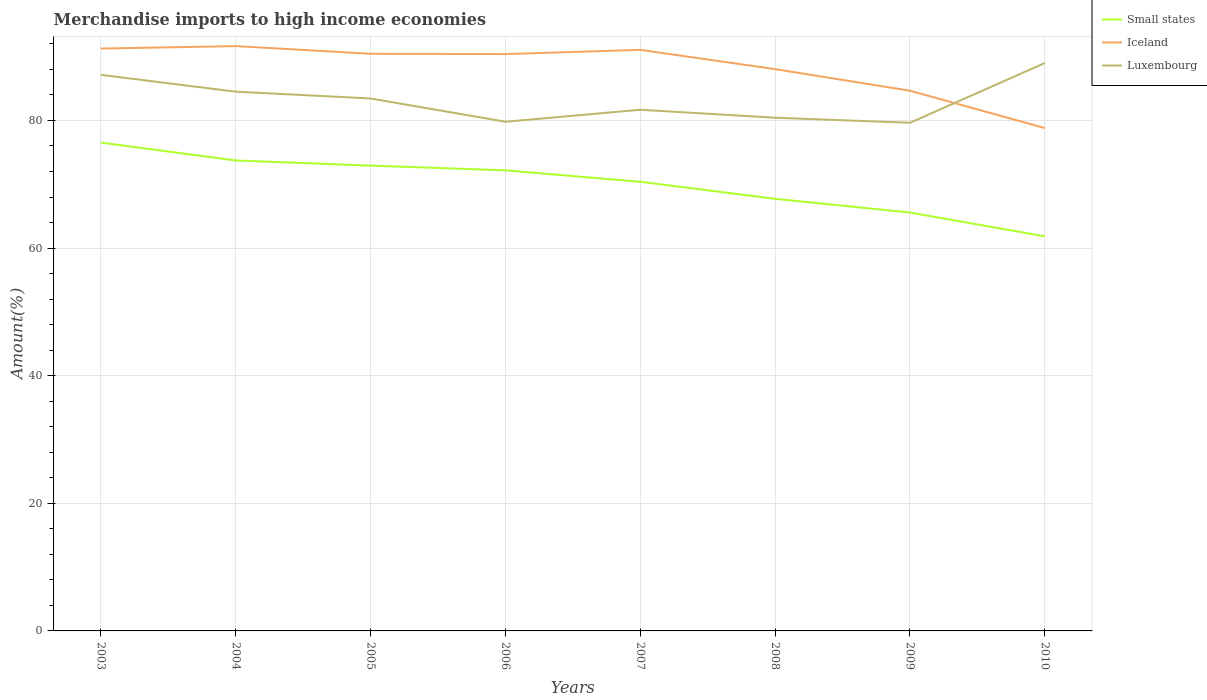Across all years, what is the maximum percentage of amount earned from merchandise imports in Luxembourg?
Offer a very short reply. 79.64. What is the total percentage of amount earned from merchandise imports in Small states in the graph?
Offer a terse response. 3.73. What is the difference between the highest and the second highest percentage of amount earned from merchandise imports in Luxembourg?
Your answer should be compact. 9.37. What is the difference between the highest and the lowest percentage of amount earned from merchandise imports in Small states?
Make the answer very short. 5. Is the percentage of amount earned from merchandise imports in Iceland strictly greater than the percentage of amount earned from merchandise imports in Luxembourg over the years?
Keep it short and to the point. No. Are the values on the major ticks of Y-axis written in scientific E-notation?
Offer a very short reply. No. Where does the legend appear in the graph?
Ensure brevity in your answer.  Top right. How many legend labels are there?
Give a very brief answer. 3. What is the title of the graph?
Your answer should be compact. Merchandise imports to high income economies. Does "Lithuania" appear as one of the legend labels in the graph?
Give a very brief answer. No. What is the label or title of the Y-axis?
Offer a terse response. Amount(%). What is the Amount(%) of Small states in 2003?
Provide a succinct answer. 76.54. What is the Amount(%) in Iceland in 2003?
Ensure brevity in your answer.  91.27. What is the Amount(%) of Luxembourg in 2003?
Keep it short and to the point. 87.15. What is the Amount(%) of Small states in 2004?
Ensure brevity in your answer.  73.73. What is the Amount(%) of Iceland in 2004?
Give a very brief answer. 91.66. What is the Amount(%) of Luxembourg in 2004?
Your response must be concise. 84.51. What is the Amount(%) in Small states in 2005?
Your response must be concise. 72.92. What is the Amount(%) of Iceland in 2005?
Provide a succinct answer. 90.45. What is the Amount(%) of Luxembourg in 2005?
Provide a short and direct response. 83.45. What is the Amount(%) in Small states in 2006?
Your response must be concise. 72.18. What is the Amount(%) of Iceland in 2006?
Offer a very short reply. 90.41. What is the Amount(%) of Luxembourg in 2006?
Provide a succinct answer. 79.8. What is the Amount(%) of Small states in 2007?
Ensure brevity in your answer.  70.39. What is the Amount(%) in Iceland in 2007?
Offer a terse response. 91.06. What is the Amount(%) in Luxembourg in 2007?
Provide a short and direct response. 81.68. What is the Amount(%) in Small states in 2008?
Give a very brief answer. 67.72. What is the Amount(%) of Iceland in 2008?
Give a very brief answer. 88.05. What is the Amount(%) in Luxembourg in 2008?
Keep it short and to the point. 80.43. What is the Amount(%) of Small states in 2009?
Your answer should be compact. 65.57. What is the Amount(%) in Iceland in 2009?
Your answer should be very brief. 84.66. What is the Amount(%) of Luxembourg in 2009?
Your response must be concise. 79.64. What is the Amount(%) of Small states in 2010?
Make the answer very short. 61.84. What is the Amount(%) in Iceland in 2010?
Your response must be concise. 78.81. What is the Amount(%) of Luxembourg in 2010?
Offer a terse response. 89. Across all years, what is the maximum Amount(%) of Small states?
Give a very brief answer. 76.54. Across all years, what is the maximum Amount(%) of Iceland?
Your response must be concise. 91.66. Across all years, what is the maximum Amount(%) of Luxembourg?
Your answer should be very brief. 89. Across all years, what is the minimum Amount(%) in Small states?
Provide a succinct answer. 61.84. Across all years, what is the minimum Amount(%) in Iceland?
Keep it short and to the point. 78.81. Across all years, what is the minimum Amount(%) in Luxembourg?
Ensure brevity in your answer.  79.64. What is the total Amount(%) of Small states in the graph?
Your answer should be compact. 560.9. What is the total Amount(%) in Iceland in the graph?
Give a very brief answer. 706.38. What is the total Amount(%) of Luxembourg in the graph?
Keep it short and to the point. 665.67. What is the difference between the Amount(%) of Small states in 2003 and that in 2004?
Ensure brevity in your answer.  2.8. What is the difference between the Amount(%) in Iceland in 2003 and that in 2004?
Your answer should be very brief. -0.39. What is the difference between the Amount(%) of Luxembourg in 2003 and that in 2004?
Offer a terse response. 2.64. What is the difference between the Amount(%) in Small states in 2003 and that in 2005?
Provide a short and direct response. 3.61. What is the difference between the Amount(%) in Iceland in 2003 and that in 2005?
Keep it short and to the point. 0.82. What is the difference between the Amount(%) in Luxembourg in 2003 and that in 2005?
Offer a very short reply. 3.7. What is the difference between the Amount(%) in Small states in 2003 and that in 2006?
Provide a short and direct response. 4.35. What is the difference between the Amount(%) in Iceland in 2003 and that in 2006?
Make the answer very short. 0.86. What is the difference between the Amount(%) of Luxembourg in 2003 and that in 2006?
Make the answer very short. 7.35. What is the difference between the Amount(%) of Small states in 2003 and that in 2007?
Your response must be concise. 6.14. What is the difference between the Amount(%) in Iceland in 2003 and that in 2007?
Ensure brevity in your answer.  0.21. What is the difference between the Amount(%) in Luxembourg in 2003 and that in 2007?
Give a very brief answer. 5.47. What is the difference between the Amount(%) in Small states in 2003 and that in 2008?
Offer a terse response. 8.82. What is the difference between the Amount(%) in Iceland in 2003 and that in 2008?
Keep it short and to the point. 3.22. What is the difference between the Amount(%) in Luxembourg in 2003 and that in 2008?
Keep it short and to the point. 6.72. What is the difference between the Amount(%) of Small states in 2003 and that in 2009?
Make the answer very short. 10.96. What is the difference between the Amount(%) in Iceland in 2003 and that in 2009?
Offer a terse response. 6.61. What is the difference between the Amount(%) of Luxembourg in 2003 and that in 2009?
Keep it short and to the point. 7.51. What is the difference between the Amount(%) in Small states in 2003 and that in 2010?
Your answer should be very brief. 14.69. What is the difference between the Amount(%) in Iceland in 2003 and that in 2010?
Ensure brevity in your answer.  12.46. What is the difference between the Amount(%) of Luxembourg in 2003 and that in 2010?
Provide a succinct answer. -1.85. What is the difference between the Amount(%) in Small states in 2004 and that in 2005?
Provide a short and direct response. 0.81. What is the difference between the Amount(%) in Iceland in 2004 and that in 2005?
Give a very brief answer. 1.21. What is the difference between the Amount(%) of Luxembourg in 2004 and that in 2005?
Give a very brief answer. 1.07. What is the difference between the Amount(%) in Small states in 2004 and that in 2006?
Your answer should be compact. 1.55. What is the difference between the Amount(%) of Iceland in 2004 and that in 2006?
Offer a terse response. 1.25. What is the difference between the Amount(%) in Luxembourg in 2004 and that in 2006?
Offer a very short reply. 4.71. What is the difference between the Amount(%) of Small states in 2004 and that in 2007?
Make the answer very short. 3.34. What is the difference between the Amount(%) in Iceland in 2004 and that in 2007?
Make the answer very short. 0.59. What is the difference between the Amount(%) in Luxembourg in 2004 and that in 2007?
Your answer should be very brief. 2.83. What is the difference between the Amount(%) in Small states in 2004 and that in 2008?
Your answer should be very brief. 6.01. What is the difference between the Amount(%) in Iceland in 2004 and that in 2008?
Ensure brevity in your answer.  3.61. What is the difference between the Amount(%) of Luxembourg in 2004 and that in 2008?
Provide a succinct answer. 4.08. What is the difference between the Amount(%) of Small states in 2004 and that in 2009?
Offer a very short reply. 8.16. What is the difference between the Amount(%) of Iceland in 2004 and that in 2009?
Make the answer very short. 7. What is the difference between the Amount(%) in Luxembourg in 2004 and that in 2009?
Your answer should be compact. 4.87. What is the difference between the Amount(%) of Small states in 2004 and that in 2010?
Ensure brevity in your answer.  11.89. What is the difference between the Amount(%) of Iceland in 2004 and that in 2010?
Your response must be concise. 12.85. What is the difference between the Amount(%) in Luxembourg in 2004 and that in 2010?
Keep it short and to the point. -4.49. What is the difference between the Amount(%) of Small states in 2005 and that in 2006?
Your answer should be compact. 0.74. What is the difference between the Amount(%) in Iceland in 2005 and that in 2006?
Your answer should be compact. 0.05. What is the difference between the Amount(%) in Luxembourg in 2005 and that in 2006?
Provide a short and direct response. 3.65. What is the difference between the Amount(%) in Small states in 2005 and that in 2007?
Provide a succinct answer. 2.53. What is the difference between the Amount(%) in Iceland in 2005 and that in 2007?
Make the answer very short. -0.61. What is the difference between the Amount(%) in Luxembourg in 2005 and that in 2007?
Offer a very short reply. 1.77. What is the difference between the Amount(%) in Small states in 2005 and that in 2008?
Give a very brief answer. 5.2. What is the difference between the Amount(%) in Iceland in 2005 and that in 2008?
Give a very brief answer. 2.4. What is the difference between the Amount(%) in Luxembourg in 2005 and that in 2008?
Give a very brief answer. 3.02. What is the difference between the Amount(%) of Small states in 2005 and that in 2009?
Make the answer very short. 7.35. What is the difference between the Amount(%) of Iceland in 2005 and that in 2009?
Give a very brief answer. 5.79. What is the difference between the Amount(%) in Luxembourg in 2005 and that in 2009?
Provide a short and direct response. 3.81. What is the difference between the Amount(%) of Small states in 2005 and that in 2010?
Provide a short and direct response. 11.08. What is the difference between the Amount(%) of Iceland in 2005 and that in 2010?
Make the answer very short. 11.64. What is the difference between the Amount(%) in Luxembourg in 2005 and that in 2010?
Your answer should be compact. -5.56. What is the difference between the Amount(%) in Small states in 2006 and that in 2007?
Your answer should be compact. 1.79. What is the difference between the Amount(%) in Iceland in 2006 and that in 2007?
Make the answer very short. -0.66. What is the difference between the Amount(%) of Luxembourg in 2006 and that in 2007?
Your response must be concise. -1.88. What is the difference between the Amount(%) in Small states in 2006 and that in 2008?
Give a very brief answer. 4.46. What is the difference between the Amount(%) of Iceland in 2006 and that in 2008?
Your answer should be very brief. 2.36. What is the difference between the Amount(%) of Luxembourg in 2006 and that in 2008?
Provide a succinct answer. -0.63. What is the difference between the Amount(%) of Small states in 2006 and that in 2009?
Offer a very short reply. 6.61. What is the difference between the Amount(%) in Iceland in 2006 and that in 2009?
Give a very brief answer. 5.74. What is the difference between the Amount(%) in Luxembourg in 2006 and that in 2009?
Your answer should be very brief. 0.16. What is the difference between the Amount(%) in Small states in 2006 and that in 2010?
Make the answer very short. 10.34. What is the difference between the Amount(%) in Iceland in 2006 and that in 2010?
Ensure brevity in your answer.  11.6. What is the difference between the Amount(%) of Luxembourg in 2006 and that in 2010?
Make the answer very short. -9.2. What is the difference between the Amount(%) in Small states in 2007 and that in 2008?
Your answer should be very brief. 2.67. What is the difference between the Amount(%) in Iceland in 2007 and that in 2008?
Provide a succinct answer. 3.02. What is the difference between the Amount(%) in Luxembourg in 2007 and that in 2008?
Make the answer very short. 1.25. What is the difference between the Amount(%) in Small states in 2007 and that in 2009?
Provide a succinct answer. 4.82. What is the difference between the Amount(%) of Iceland in 2007 and that in 2009?
Your answer should be very brief. 6.4. What is the difference between the Amount(%) of Luxembourg in 2007 and that in 2009?
Provide a short and direct response. 2.04. What is the difference between the Amount(%) in Small states in 2007 and that in 2010?
Give a very brief answer. 8.55. What is the difference between the Amount(%) in Iceland in 2007 and that in 2010?
Ensure brevity in your answer.  12.25. What is the difference between the Amount(%) of Luxembourg in 2007 and that in 2010?
Your response must be concise. -7.32. What is the difference between the Amount(%) of Small states in 2008 and that in 2009?
Give a very brief answer. 2.15. What is the difference between the Amount(%) in Iceland in 2008 and that in 2009?
Give a very brief answer. 3.39. What is the difference between the Amount(%) of Luxembourg in 2008 and that in 2009?
Give a very brief answer. 0.79. What is the difference between the Amount(%) of Small states in 2008 and that in 2010?
Provide a succinct answer. 5.87. What is the difference between the Amount(%) of Iceland in 2008 and that in 2010?
Your response must be concise. 9.24. What is the difference between the Amount(%) in Luxembourg in 2008 and that in 2010?
Offer a terse response. -8.57. What is the difference between the Amount(%) in Small states in 2009 and that in 2010?
Provide a short and direct response. 3.73. What is the difference between the Amount(%) of Iceland in 2009 and that in 2010?
Provide a succinct answer. 5.85. What is the difference between the Amount(%) of Luxembourg in 2009 and that in 2010?
Keep it short and to the point. -9.37. What is the difference between the Amount(%) of Small states in 2003 and the Amount(%) of Iceland in 2004?
Your answer should be compact. -15.12. What is the difference between the Amount(%) in Small states in 2003 and the Amount(%) in Luxembourg in 2004?
Make the answer very short. -7.98. What is the difference between the Amount(%) of Iceland in 2003 and the Amount(%) of Luxembourg in 2004?
Your answer should be very brief. 6.76. What is the difference between the Amount(%) of Small states in 2003 and the Amount(%) of Iceland in 2005?
Keep it short and to the point. -13.92. What is the difference between the Amount(%) in Small states in 2003 and the Amount(%) in Luxembourg in 2005?
Ensure brevity in your answer.  -6.91. What is the difference between the Amount(%) of Iceland in 2003 and the Amount(%) of Luxembourg in 2005?
Give a very brief answer. 7.82. What is the difference between the Amount(%) of Small states in 2003 and the Amount(%) of Iceland in 2006?
Keep it short and to the point. -13.87. What is the difference between the Amount(%) of Small states in 2003 and the Amount(%) of Luxembourg in 2006?
Give a very brief answer. -3.26. What is the difference between the Amount(%) of Iceland in 2003 and the Amount(%) of Luxembourg in 2006?
Keep it short and to the point. 11.47. What is the difference between the Amount(%) in Small states in 2003 and the Amount(%) in Iceland in 2007?
Ensure brevity in your answer.  -14.53. What is the difference between the Amount(%) of Small states in 2003 and the Amount(%) of Luxembourg in 2007?
Your answer should be very brief. -5.15. What is the difference between the Amount(%) of Iceland in 2003 and the Amount(%) of Luxembourg in 2007?
Your answer should be compact. 9.59. What is the difference between the Amount(%) in Small states in 2003 and the Amount(%) in Iceland in 2008?
Keep it short and to the point. -11.51. What is the difference between the Amount(%) in Small states in 2003 and the Amount(%) in Luxembourg in 2008?
Offer a very short reply. -3.9. What is the difference between the Amount(%) of Iceland in 2003 and the Amount(%) of Luxembourg in 2008?
Your answer should be compact. 10.84. What is the difference between the Amount(%) of Small states in 2003 and the Amount(%) of Iceland in 2009?
Offer a very short reply. -8.13. What is the difference between the Amount(%) of Small states in 2003 and the Amount(%) of Luxembourg in 2009?
Your answer should be very brief. -3.1. What is the difference between the Amount(%) of Iceland in 2003 and the Amount(%) of Luxembourg in 2009?
Your answer should be compact. 11.63. What is the difference between the Amount(%) of Small states in 2003 and the Amount(%) of Iceland in 2010?
Your answer should be compact. -2.28. What is the difference between the Amount(%) of Small states in 2003 and the Amount(%) of Luxembourg in 2010?
Give a very brief answer. -12.47. What is the difference between the Amount(%) in Iceland in 2003 and the Amount(%) in Luxembourg in 2010?
Ensure brevity in your answer.  2.27. What is the difference between the Amount(%) in Small states in 2004 and the Amount(%) in Iceland in 2005?
Keep it short and to the point. -16.72. What is the difference between the Amount(%) in Small states in 2004 and the Amount(%) in Luxembourg in 2005?
Give a very brief answer. -9.72. What is the difference between the Amount(%) in Iceland in 2004 and the Amount(%) in Luxembourg in 2005?
Your answer should be very brief. 8.21. What is the difference between the Amount(%) in Small states in 2004 and the Amount(%) in Iceland in 2006?
Give a very brief answer. -16.68. What is the difference between the Amount(%) in Small states in 2004 and the Amount(%) in Luxembourg in 2006?
Your response must be concise. -6.07. What is the difference between the Amount(%) of Iceland in 2004 and the Amount(%) of Luxembourg in 2006?
Make the answer very short. 11.86. What is the difference between the Amount(%) in Small states in 2004 and the Amount(%) in Iceland in 2007?
Provide a succinct answer. -17.33. What is the difference between the Amount(%) of Small states in 2004 and the Amount(%) of Luxembourg in 2007?
Provide a succinct answer. -7.95. What is the difference between the Amount(%) in Iceland in 2004 and the Amount(%) in Luxembourg in 2007?
Keep it short and to the point. 9.98. What is the difference between the Amount(%) of Small states in 2004 and the Amount(%) of Iceland in 2008?
Make the answer very short. -14.32. What is the difference between the Amount(%) in Small states in 2004 and the Amount(%) in Luxembourg in 2008?
Offer a very short reply. -6.7. What is the difference between the Amount(%) of Iceland in 2004 and the Amount(%) of Luxembourg in 2008?
Provide a succinct answer. 11.23. What is the difference between the Amount(%) in Small states in 2004 and the Amount(%) in Iceland in 2009?
Make the answer very short. -10.93. What is the difference between the Amount(%) of Small states in 2004 and the Amount(%) of Luxembourg in 2009?
Ensure brevity in your answer.  -5.91. What is the difference between the Amount(%) of Iceland in 2004 and the Amount(%) of Luxembourg in 2009?
Keep it short and to the point. 12.02. What is the difference between the Amount(%) of Small states in 2004 and the Amount(%) of Iceland in 2010?
Your answer should be compact. -5.08. What is the difference between the Amount(%) of Small states in 2004 and the Amount(%) of Luxembourg in 2010?
Your response must be concise. -15.27. What is the difference between the Amount(%) in Iceland in 2004 and the Amount(%) in Luxembourg in 2010?
Offer a terse response. 2.65. What is the difference between the Amount(%) in Small states in 2005 and the Amount(%) in Iceland in 2006?
Your answer should be compact. -17.48. What is the difference between the Amount(%) of Small states in 2005 and the Amount(%) of Luxembourg in 2006?
Offer a very short reply. -6.88. What is the difference between the Amount(%) in Iceland in 2005 and the Amount(%) in Luxembourg in 2006?
Give a very brief answer. 10.65. What is the difference between the Amount(%) in Small states in 2005 and the Amount(%) in Iceland in 2007?
Keep it short and to the point. -18.14. What is the difference between the Amount(%) of Small states in 2005 and the Amount(%) of Luxembourg in 2007?
Provide a succinct answer. -8.76. What is the difference between the Amount(%) of Iceland in 2005 and the Amount(%) of Luxembourg in 2007?
Give a very brief answer. 8.77. What is the difference between the Amount(%) of Small states in 2005 and the Amount(%) of Iceland in 2008?
Keep it short and to the point. -15.13. What is the difference between the Amount(%) of Small states in 2005 and the Amount(%) of Luxembourg in 2008?
Provide a succinct answer. -7.51. What is the difference between the Amount(%) of Iceland in 2005 and the Amount(%) of Luxembourg in 2008?
Offer a very short reply. 10.02. What is the difference between the Amount(%) of Small states in 2005 and the Amount(%) of Iceland in 2009?
Offer a terse response. -11.74. What is the difference between the Amount(%) in Small states in 2005 and the Amount(%) in Luxembourg in 2009?
Offer a terse response. -6.72. What is the difference between the Amount(%) of Iceland in 2005 and the Amount(%) of Luxembourg in 2009?
Your answer should be very brief. 10.81. What is the difference between the Amount(%) of Small states in 2005 and the Amount(%) of Iceland in 2010?
Offer a very short reply. -5.89. What is the difference between the Amount(%) of Small states in 2005 and the Amount(%) of Luxembourg in 2010?
Provide a short and direct response. -16.08. What is the difference between the Amount(%) of Iceland in 2005 and the Amount(%) of Luxembourg in 2010?
Your answer should be compact. 1.45. What is the difference between the Amount(%) of Small states in 2006 and the Amount(%) of Iceland in 2007?
Your answer should be very brief. -18.88. What is the difference between the Amount(%) in Small states in 2006 and the Amount(%) in Luxembourg in 2007?
Provide a succinct answer. -9.5. What is the difference between the Amount(%) in Iceland in 2006 and the Amount(%) in Luxembourg in 2007?
Your answer should be very brief. 8.73. What is the difference between the Amount(%) in Small states in 2006 and the Amount(%) in Iceland in 2008?
Your response must be concise. -15.87. What is the difference between the Amount(%) in Small states in 2006 and the Amount(%) in Luxembourg in 2008?
Give a very brief answer. -8.25. What is the difference between the Amount(%) of Iceland in 2006 and the Amount(%) of Luxembourg in 2008?
Offer a very short reply. 9.97. What is the difference between the Amount(%) of Small states in 2006 and the Amount(%) of Iceland in 2009?
Provide a succinct answer. -12.48. What is the difference between the Amount(%) of Small states in 2006 and the Amount(%) of Luxembourg in 2009?
Keep it short and to the point. -7.46. What is the difference between the Amount(%) of Iceland in 2006 and the Amount(%) of Luxembourg in 2009?
Give a very brief answer. 10.77. What is the difference between the Amount(%) in Small states in 2006 and the Amount(%) in Iceland in 2010?
Your answer should be compact. -6.63. What is the difference between the Amount(%) of Small states in 2006 and the Amount(%) of Luxembourg in 2010?
Provide a succinct answer. -16.82. What is the difference between the Amount(%) in Iceland in 2006 and the Amount(%) in Luxembourg in 2010?
Your answer should be very brief. 1.4. What is the difference between the Amount(%) in Small states in 2007 and the Amount(%) in Iceland in 2008?
Your answer should be very brief. -17.66. What is the difference between the Amount(%) of Small states in 2007 and the Amount(%) of Luxembourg in 2008?
Provide a short and direct response. -10.04. What is the difference between the Amount(%) of Iceland in 2007 and the Amount(%) of Luxembourg in 2008?
Make the answer very short. 10.63. What is the difference between the Amount(%) in Small states in 2007 and the Amount(%) in Iceland in 2009?
Your answer should be very brief. -14.27. What is the difference between the Amount(%) in Small states in 2007 and the Amount(%) in Luxembourg in 2009?
Offer a very short reply. -9.25. What is the difference between the Amount(%) in Iceland in 2007 and the Amount(%) in Luxembourg in 2009?
Your answer should be compact. 11.43. What is the difference between the Amount(%) of Small states in 2007 and the Amount(%) of Iceland in 2010?
Offer a terse response. -8.42. What is the difference between the Amount(%) in Small states in 2007 and the Amount(%) in Luxembourg in 2010?
Provide a succinct answer. -18.61. What is the difference between the Amount(%) of Iceland in 2007 and the Amount(%) of Luxembourg in 2010?
Your answer should be very brief. 2.06. What is the difference between the Amount(%) in Small states in 2008 and the Amount(%) in Iceland in 2009?
Your response must be concise. -16.94. What is the difference between the Amount(%) of Small states in 2008 and the Amount(%) of Luxembourg in 2009?
Your answer should be compact. -11.92. What is the difference between the Amount(%) in Iceland in 2008 and the Amount(%) in Luxembourg in 2009?
Provide a short and direct response. 8.41. What is the difference between the Amount(%) of Small states in 2008 and the Amount(%) of Iceland in 2010?
Give a very brief answer. -11.09. What is the difference between the Amount(%) in Small states in 2008 and the Amount(%) in Luxembourg in 2010?
Provide a succinct answer. -21.29. What is the difference between the Amount(%) in Iceland in 2008 and the Amount(%) in Luxembourg in 2010?
Provide a short and direct response. -0.96. What is the difference between the Amount(%) in Small states in 2009 and the Amount(%) in Iceland in 2010?
Your answer should be compact. -13.24. What is the difference between the Amount(%) of Small states in 2009 and the Amount(%) of Luxembourg in 2010?
Your answer should be compact. -23.43. What is the difference between the Amount(%) of Iceland in 2009 and the Amount(%) of Luxembourg in 2010?
Make the answer very short. -4.34. What is the average Amount(%) of Small states per year?
Provide a short and direct response. 70.11. What is the average Amount(%) of Iceland per year?
Your answer should be very brief. 88.3. What is the average Amount(%) of Luxembourg per year?
Keep it short and to the point. 83.21. In the year 2003, what is the difference between the Amount(%) in Small states and Amount(%) in Iceland?
Offer a very short reply. -14.74. In the year 2003, what is the difference between the Amount(%) in Small states and Amount(%) in Luxembourg?
Provide a succinct answer. -10.62. In the year 2003, what is the difference between the Amount(%) in Iceland and Amount(%) in Luxembourg?
Provide a succinct answer. 4.12. In the year 2004, what is the difference between the Amount(%) in Small states and Amount(%) in Iceland?
Provide a succinct answer. -17.93. In the year 2004, what is the difference between the Amount(%) of Small states and Amount(%) of Luxembourg?
Your answer should be very brief. -10.78. In the year 2004, what is the difference between the Amount(%) in Iceland and Amount(%) in Luxembourg?
Keep it short and to the point. 7.15. In the year 2005, what is the difference between the Amount(%) in Small states and Amount(%) in Iceland?
Ensure brevity in your answer.  -17.53. In the year 2005, what is the difference between the Amount(%) of Small states and Amount(%) of Luxembourg?
Offer a very short reply. -10.53. In the year 2005, what is the difference between the Amount(%) of Iceland and Amount(%) of Luxembourg?
Ensure brevity in your answer.  7. In the year 2006, what is the difference between the Amount(%) in Small states and Amount(%) in Iceland?
Provide a succinct answer. -18.22. In the year 2006, what is the difference between the Amount(%) of Small states and Amount(%) of Luxembourg?
Your answer should be very brief. -7.62. In the year 2006, what is the difference between the Amount(%) of Iceland and Amount(%) of Luxembourg?
Your answer should be compact. 10.61. In the year 2007, what is the difference between the Amount(%) of Small states and Amount(%) of Iceland?
Keep it short and to the point. -20.67. In the year 2007, what is the difference between the Amount(%) in Small states and Amount(%) in Luxembourg?
Your answer should be compact. -11.29. In the year 2007, what is the difference between the Amount(%) in Iceland and Amount(%) in Luxembourg?
Your response must be concise. 9.38. In the year 2008, what is the difference between the Amount(%) in Small states and Amount(%) in Iceland?
Give a very brief answer. -20.33. In the year 2008, what is the difference between the Amount(%) of Small states and Amount(%) of Luxembourg?
Keep it short and to the point. -12.71. In the year 2008, what is the difference between the Amount(%) of Iceland and Amount(%) of Luxembourg?
Make the answer very short. 7.62. In the year 2009, what is the difference between the Amount(%) in Small states and Amount(%) in Iceland?
Keep it short and to the point. -19.09. In the year 2009, what is the difference between the Amount(%) in Small states and Amount(%) in Luxembourg?
Your answer should be very brief. -14.07. In the year 2009, what is the difference between the Amount(%) of Iceland and Amount(%) of Luxembourg?
Ensure brevity in your answer.  5.02. In the year 2010, what is the difference between the Amount(%) of Small states and Amount(%) of Iceland?
Offer a very short reply. -16.97. In the year 2010, what is the difference between the Amount(%) of Small states and Amount(%) of Luxembourg?
Keep it short and to the point. -27.16. In the year 2010, what is the difference between the Amount(%) of Iceland and Amount(%) of Luxembourg?
Your response must be concise. -10.19. What is the ratio of the Amount(%) of Small states in 2003 to that in 2004?
Give a very brief answer. 1.04. What is the ratio of the Amount(%) in Luxembourg in 2003 to that in 2004?
Your answer should be very brief. 1.03. What is the ratio of the Amount(%) of Small states in 2003 to that in 2005?
Give a very brief answer. 1.05. What is the ratio of the Amount(%) in Iceland in 2003 to that in 2005?
Keep it short and to the point. 1.01. What is the ratio of the Amount(%) of Luxembourg in 2003 to that in 2005?
Provide a succinct answer. 1.04. What is the ratio of the Amount(%) in Small states in 2003 to that in 2006?
Your answer should be compact. 1.06. What is the ratio of the Amount(%) in Iceland in 2003 to that in 2006?
Provide a succinct answer. 1.01. What is the ratio of the Amount(%) of Luxembourg in 2003 to that in 2006?
Your answer should be very brief. 1.09. What is the ratio of the Amount(%) in Small states in 2003 to that in 2007?
Offer a terse response. 1.09. What is the ratio of the Amount(%) of Luxembourg in 2003 to that in 2007?
Ensure brevity in your answer.  1.07. What is the ratio of the Amount(%) in Small states in 2003 to that in 2008?
Make the answer very short. 1.13. What is the ratio of the Amount(%) in Iceland in 2003 to that in 2008?
Provide a short and direct response. 1.04. What is the ratio of the Amount(%) of Luxembourg in 2003 to that in 2008?
Provide a succinct answer. 1.08. What is the ratio of the Amount(%) in Small states in 2003 to that in 2009?
Your response must be concise. 1.17. What is the ratio of the Amount(%) in Iceland in 2003 to that in 2009?
Provide a succinct answer. 1.08. What is the ratio of the Amount(%) in Luxembourg in 2003 to that in 2009?
Ensure brevity in your answer.  1.09. What is the ratio of the Amount(%) of Small states in 2003 to that in 2010?
Ensure brevity in your answer.  1.24. What is the ratio of the Amount(%) of Iceland in 2003 to that in 2010?
Your answer should be very brief. 1.16. What is the ratio of the Amount(%) of Luxembourg in 2003 to that in 2010?
Ensure brevity in your answer.  0.98. What is the ratio of the Amount(%) of Small states in 2004 to that in 2005?
Offer a very short reply. 1.01. What is the ratio of the Amount(%) in Iceland in 2004 to that in 2005?
Keep it short and to the point. 1.01. What is the ratio of the Amount(%) in Luxembourg in 2004 to that in 2005?
Your answer should be compact. 1.01. What is the ratio of the Amount(%) in Small states in 2004 to that in 2006?
Offer a very short reply. 1.02. What is the ratio of the Amount(%) of Iceland in 2004 to that in 2006?
Give a very brief answer. 1.01. What is the ratio of the Amount(%) of Luxembourg in 2004 to that in 2006?
Your answer should be very brief. 1.06. What is the ratio of the Amount(%) in Small states in 2004 to that in 2007?
Provide a short and direct response. 1.05. What is the ratio of the Amount(%) in Luxembourg in 2004 to that in 2007?
Your answer should be compact. 1.03. What is the ratio of the Amount(%) in Small states in 2004 to that in 2008?
Offer a terse response. 1.09. What is the ratio of the Amount(%) in Iceland in 2004 to that in 2008?
Your response must be concise. 1.04. What is the ratio of the Amount(%) of Luxembourg in 2004 to that in 2008?
Offer a very short reply. 1.05. What is the ratio of the Amount(%) of Small states in 2004 to that in 2009?
Offer a very short reply. 1.12. What is the ratio of the Amount(%) in Iceland in 2004 to that in 2009?
Your answer should be compact. 1.08. What is the ratio of the Amount(%) in Luxembourg in 2004 to that in 2009?
Offer a terse response. 1.06. What is the ratio of the Amount(%) of Small states in 2004 to that in 2010?
Ensure brevity in your answer.  1.19. What is the ratio of the Amount(%) of Iceland in 2004 to that in 2010?
Offer a very short reply. 1.16. What is the ratio of the Amount(%) of Luxembourg in 2004 to that in 2010?
Your answer should be very brief. 0.95. What is the ratio of the Amount(%) in Small states in 2005 to that in 2006?
Make the answer very short. 1.01. What is the ratio of the Amount(%) in Luxembourg in 2005 to that in 2006?
Make the answer very short. 1.05. What is the ratio of the Amount(%) of Small states in 2005 to that in 2007?
Offer a terse response. 1.04. What is the ratio of the Amount(%) in Iceland in 2005 to that in 2007?
Offer a terse response. 0.99. What is the ratio of the Amount(%) in Luxembourg in 2005 to that in 2007?
Your answer should be very brief. 1.02. What is the ratio of the Amount(%) of Small states in 2005 to that in 2008?
Provide a succinct answer. 1.08. What is the ratio of the Amount(%) of Iceland in 2005 to that in 2008?
Your answer should be very brief. 1.03. What is the ratio of the Amount(%) in Luxembourg in 2005 to that in 2008?
Your response must be concise. 1.04. What is the ratio of the Amount(%) in Small states in 2005 to that in 2009?
Provide a short and direct response. 1.11. What is the ratio of the Amount(%) in Iceland in 2005 to that in 2009?
Give a very brief answer. 1.07. What is the ratio of the Amount(%) in Luxembourg in 2005 to that in 2009?
Make the answer very short. 1.05. What is the ratio of the Amount(%) of Small states in 2005 to that in 2010?
Ensure brevity in your answer.  1.18. What is the ratio of the Amount(%) of Iceland in 2005 to that in 2010?
Offer a very short reply. 1.15. What is the ratio of the Amount(%) in Luxembourg in 2005 to that in 2010?
Provide a succinct answer. 0.94. What is the ratio of the Amount(%) in Small states in 2006 to that in 2007?
Offer a very short reply. 1.03. What is the ratio of the Amount(%) in Iceland in 2006 to that in 2007?
Offer a terse response. 0.99. What is the ratio of the Amount(%) of Small states in 2006 to that in 2008?
Give a very brief answer. 1.07. What is the ratio of the Amount(%) of Iceland in 2006 to that in 2008?
Offer a very short reply. 1.03. What is the ratio of the Amount(%) in Luxembourg in 2006 to that in 2008?
Your answer should be very brief. 0.99. What is the ratio of the Amount(%) of Small states in 2006 to that in 2009?
Your answer should be compact. 1.1. What is the ratio of the Amount(%) of Iceland in 2006 to that in 2009?
Offer a terse response. 1.07. What is the ratio of the Amount(%) in Luxembourg in 2006 to that in 2009?
Your response must be concise. 1. What is the ratio of the Amount(%) of Small states in 2006 to that in 2010?
Give a very brief answer. 1.17. What is the ratio of the Amount(%) in Iceland in 2006 to that in 2010?
Keep it short and to the point. 1.15. What is the ratio of the Amount(%) of Luxembourg in 2006 to that in 2010?
Your answer should be compact. 0.9. What is the ratio of the Amount(%) of Small states in 2007 to that in 2008?
Keep it short and to the point. 1.04. What is the ratio of the Amount(%) in Iceland in 2007 to that in 2008?
Offer a terse response. 1.03. What is the ratio of the Amount(%) in Luxembourg in 2007 to that in 2008?
Your response must be concise. 1.02. What is the ratio of the Amount(%) of Small states in 2007 to that in 2009?
Provide a succinct answer. 1.07. What is the ratio of the Amount(%) of Iceland in 2007 to that in 2009?
Your answer should be compact. 1.08. What is the ratio of the Amount(%) in Luxembourg in 2007 to that in 2009?
Make the answer very short. 1.03. What is the ratio of the Amount(%) in Small states in 2007 to that in 2010?
Your answer should be compact. 1.14. What is the ratio of the Amount(%) in Iceland in 2007 to that in 2010?
Your answer should be very brief. 1.16. What is the ratio of the Amount(%) in Luxembourg in 2007 to that in 2010?
Provide a short and direct response. 0.92. What is the ratio of the Amount(%) of Small states in 2008 to that in 2009?
Provide a succinct answer. 1.03. What is the ratio of the Amount(%) of Luxembourg in 2008 to that in 2009?
Ensure brevity in your answer.  1.01. What is the ratio of the Amount(%) of Small states in 2008 to that in 2010?
Your response must be concise. 1.09. What is the ratio of the Amount(%) in Iceland in 2008 to that in 2010?
Offer a terse response. 1.12. What is the ratio of the Amount(%) in Luxembourg in 2008 to that in 2010?
Offer a very short reply. 0.9. What is the ratio of the Amount(%) in Small states in 2009 to that in 2010?
Ensure brevity in your answer.  1.06. What is the ratio of the Amount(%) of Iceland in 2009 to that in 2010?
Make the answer very short. 1.07. What is the ratio of the Amount(%) in Luxembourg in 2009 to that in 2010?
Your response must be concise. 0.89. What is the difference between the highest and the second highest Amount(%) in Small states?
Provide a short and direct response. 2.8. What is the difference between the highest and the second highest Amount(%) in Iceland?
Provide a succinct answer. 0.39. What is the difference between the highest and the second highest Amount(%) of Luxembourg?
Your answer should be compact. 1.85. What is the difference between the highest and the lowest Amount(%) of Small states?
Provide a short and direct response. 14.69. What is the difference between the highest and the lowest Amount(%) in Iceland?
Provide a succinct answer. 12.85. What is the difference between the highest and the lowest Amount(%) in Luxembourg?
Provide a short and direct response. 9.37. 